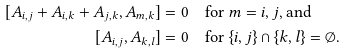Convert formula to latex. <formula><loc_0><loc_0><loc_500><loc_500>[ A _ { i , j } + A _ { i , k } + A _ { j , k } , A _ { m , k } ] & = 0 \quad \text {for $m=i,j$, and} \\ [ A _ { i , j } , A _ { k , l } ] & = 0 \quad \text {for $\{i,j\}\cap\{k,l\}=\emptyset$.}</formula> 